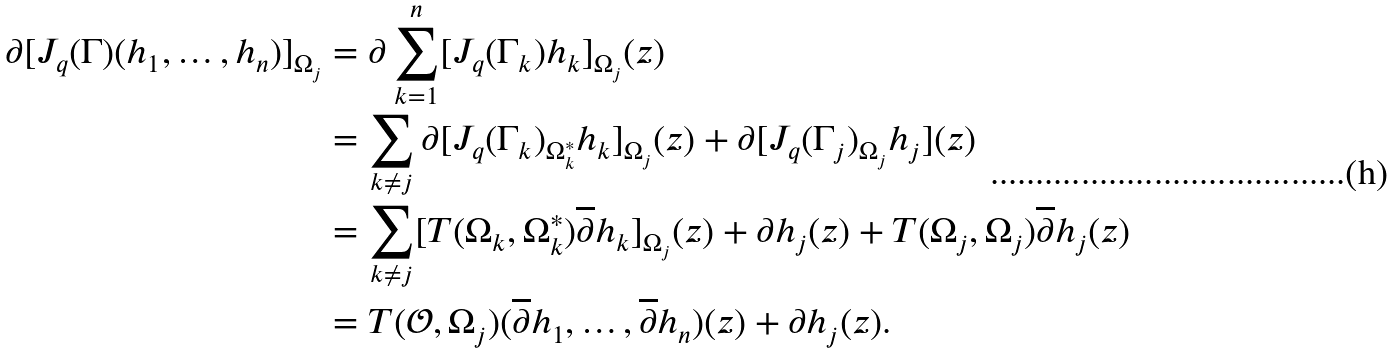Convert formula to latex. <formula><loc_0><loc_0><loc_500><loc_500>\partial [ J _ { q } ( \Gamma ) ( h _ { 1 } , \dots , h _ { n } ) ] _ { \Omega _ { j } } & = \partial \sum _ { k = 1 } ^ { n } [ J _ { q } ( \Gamma _ { k } ) h _ { k } ] _ { \Omega _ { j } } ( z ) \\ & = \sum _ { k \neq j } \partial [ J _ { q } ( \Gamma _ { k } ) _ { \Omega ^ { * } _ { k } } h _ { k } ] _ { \Omega _ { j } } ( z ) + \partial [ J _ { q } ( \Gamma _ { j } ) _ { \Omega _ { j } } h _ { j } ] ( z ) \\ & = \sum _ { k \neq j } [ T ( \Omega _ { k } , \Omega ^ { * } _ { k } ) \overline { \partial } h _ { k } ] _ { \Omega _ { j } } ( z ) + \partial h _ { j } ( z ) + T ( \Omega _ { j } , \Omega _ { j } ) \overline { \partial } h _ { j } ( z ) \\ & = T ( \mathcal { O } , \Omega _ { j } ) ( \overline { \partial } h _ { 1 } , \dots , \overline { \partial } h _ { n } ) ( z ) + \partial h _ { j } ( z ) .</formula> 